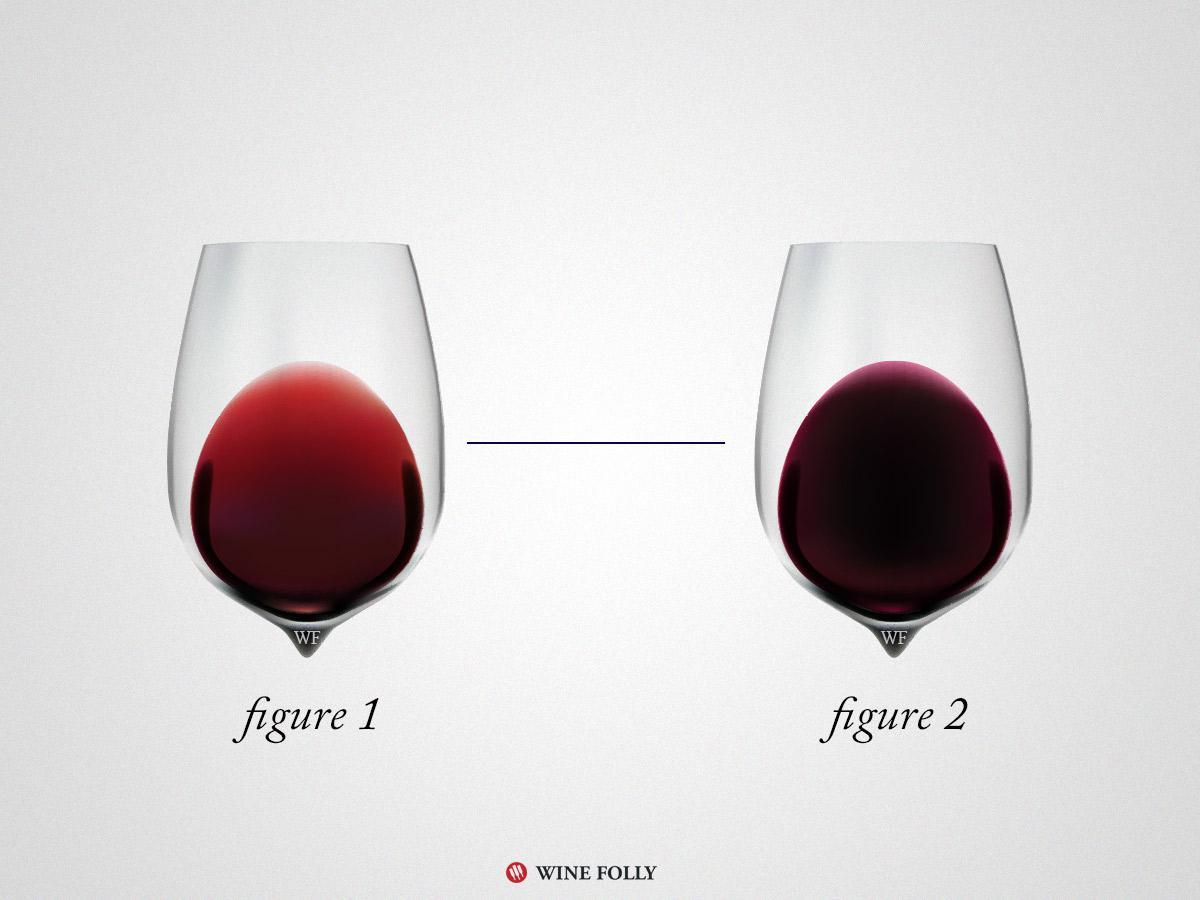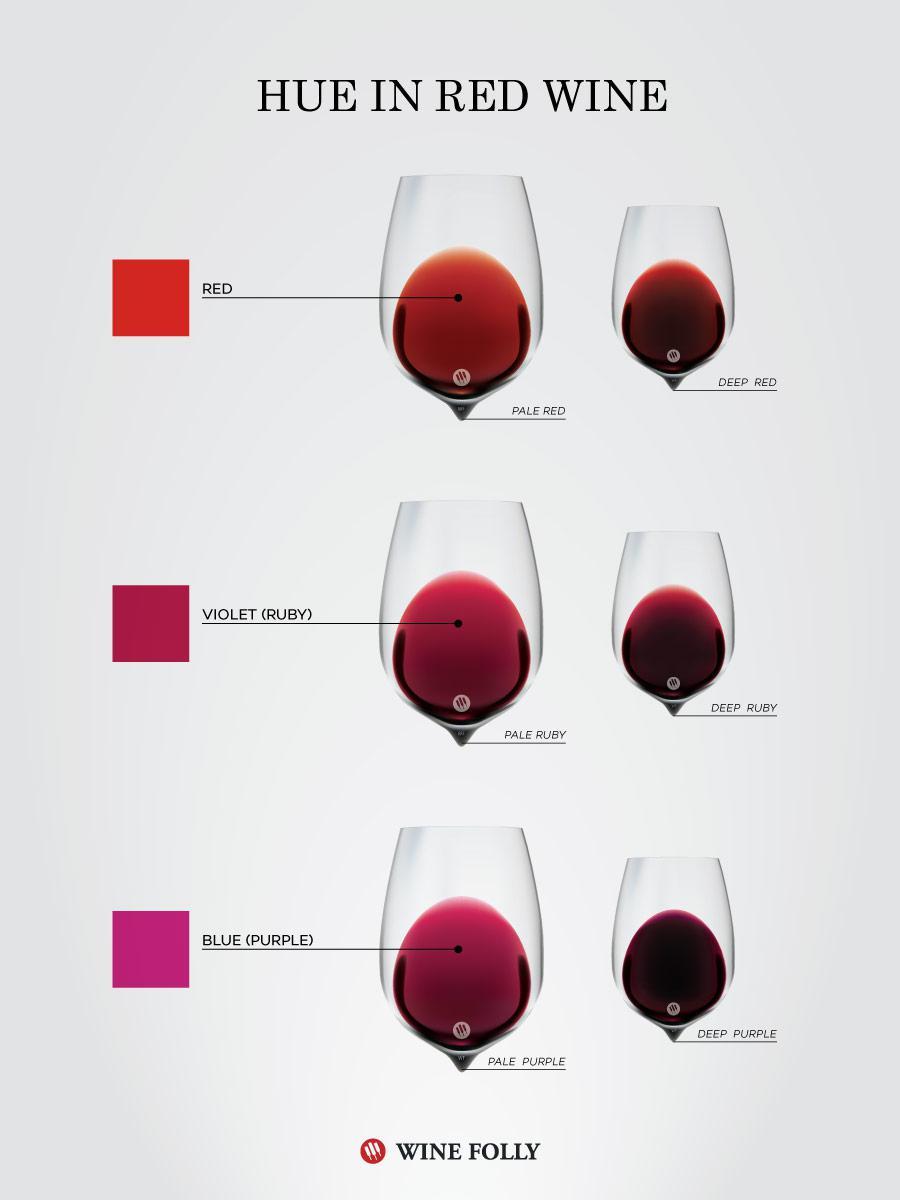The first image is the image on the left, the second image is the image on the right. For the images displayed, is the sentence "there are exactly two wine glasses in the image on the right." factually correct? Answer yes or no. No. 